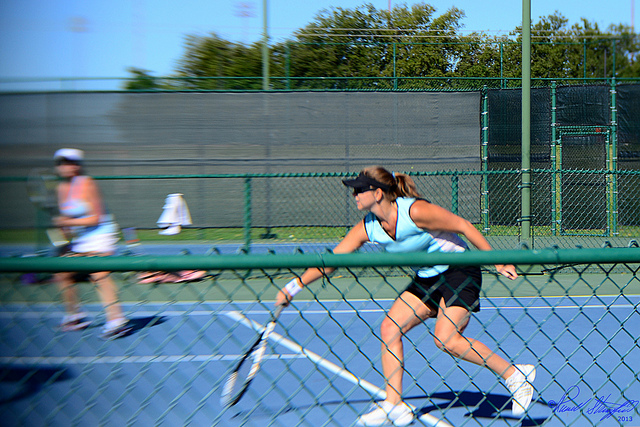What does the players' attire suggest about the level of this match? The players are wearing athletic, comfortable clothing appropriate for a tennis match. This attire is common in both casual and competitive settings, so without additional context, it's not possible to precisely determine the level of play just from their outfits. 